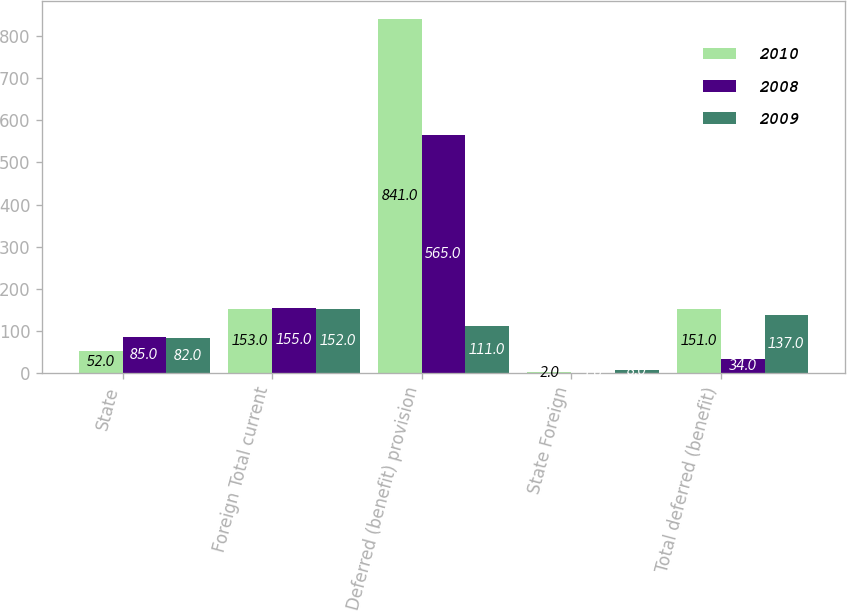Convert chart to OTSL. <chart><loc_0><loc_0><loc_500><loc_500><stacked_bar_chart><ecel><fcel>State<fcel>Foreign Total current<fcel>Deferred (benefit) provision<fcel>State Foreign<fcel>Total deferred (benefit)<nl><fcel>2010<fcel>52<fcel>153<fcel>841<fcel>2<fcel>151<nl><fcel>2008<fcel>85<fcel>155<fcel>565<fcel>1<fcel>34<nl><fcel>2009<fcel>82<fcel>152<fcel>111<fcel>8<fcel>137<nl></chart> 